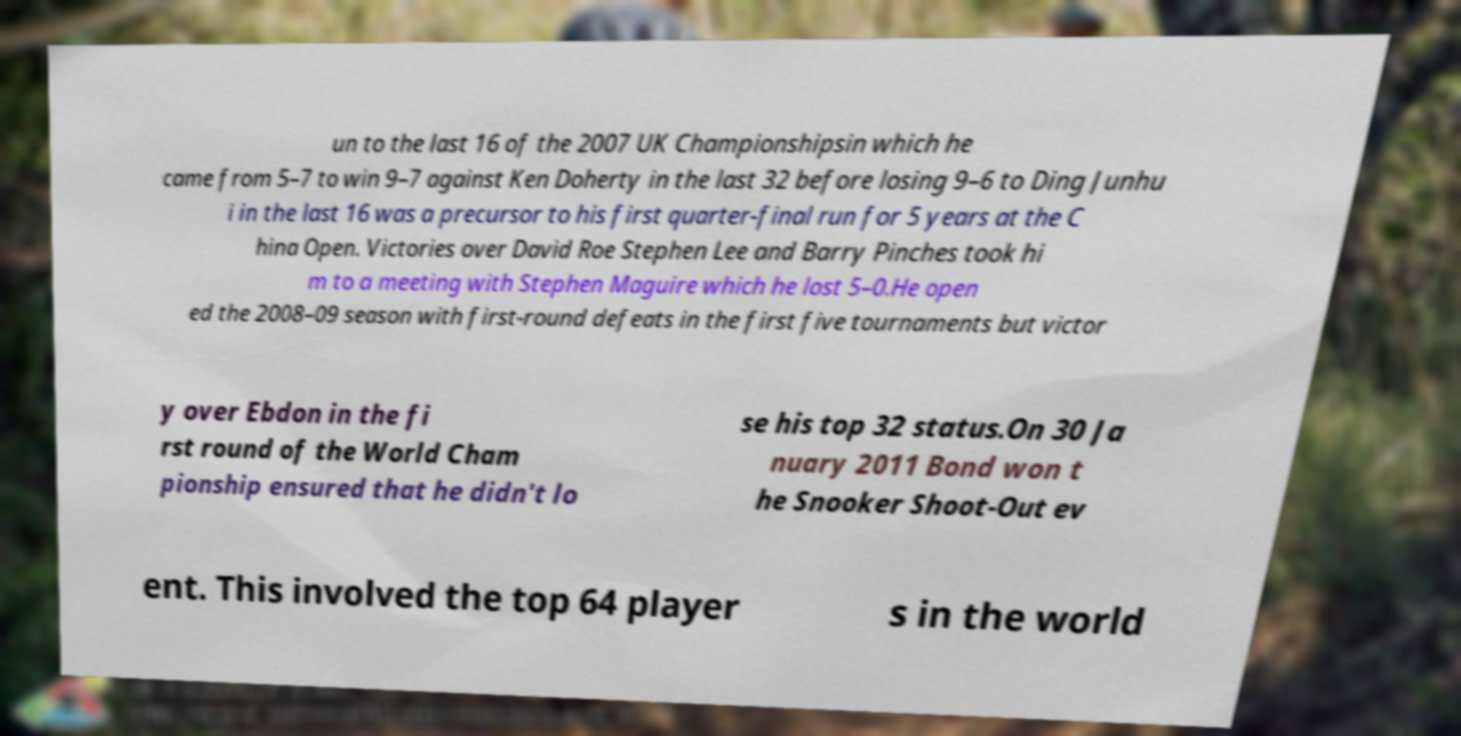Please identify and transcribe the text found in this image. un to the last 16 of the 2007 UK Championshipsin which he came from 5–7 to win 9–7 against Ken Doherty in the last 32 before losing 9–6 to Ding Junhu i in the last 16 was a precursor to his first quarter-final run for 5 years at the C hina Open. Victories over David Roe Stephen Lee and Barry Pinches took hi m to a meeting with Stephen Maguire which he lost 5–0.He open ed the 2008–09 season with first-round defeats in the first five tournaments but victor y over Ebdon in the fi rst round of the World Cham pionship ensured that he didn't lo se his top 32 status.On 30 Ja nuary 2011 Bond won t he Snooker Shoot-Out ev ent. This involved the top 64 player s in the world 